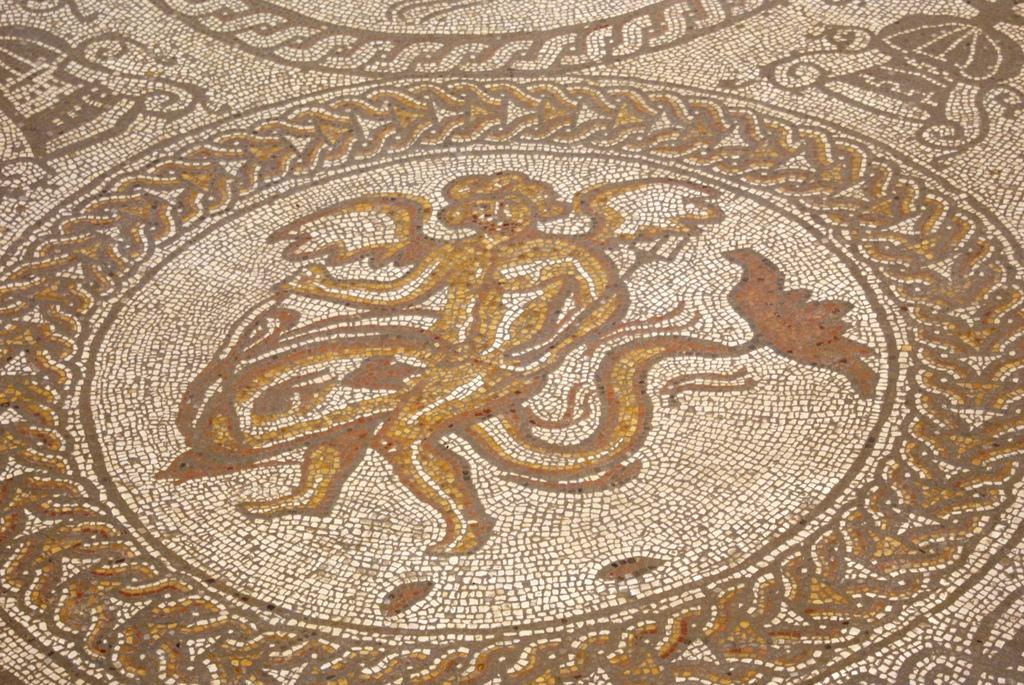What can be seen on the ground in the image? There is a painting on the ground in the image. What colors are used in the painting? The painting has cream, yellow, brown, and red colors. Can you describe the ground's appearance in the image? The ground is visible in the image, but no specific details about its appearance are provided. How many friends are depicted in the painting on the ground? There is no indication of any friends or people in the painting, as it only features colors and no discernible figures. 